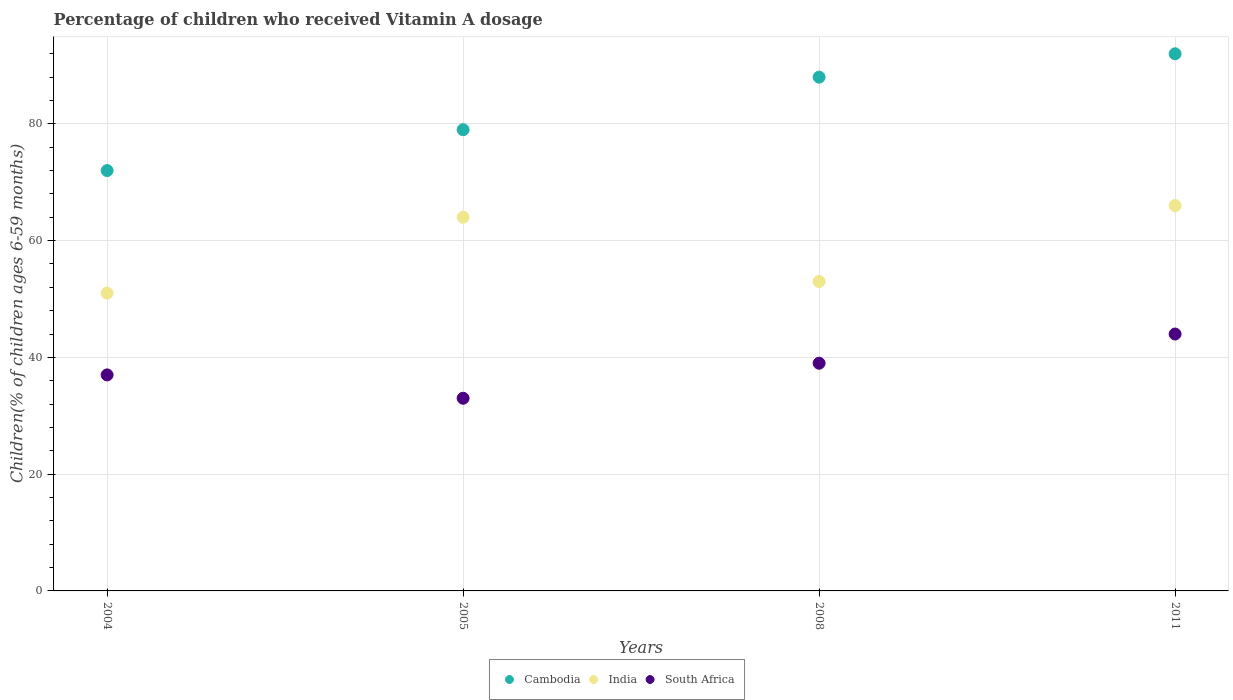Is the number of dotlines equal to the number of legend labels?
Offer a very short reply. Yes. Across all years, what is the maximum percentage of children who received Vitamin A dosage in India?
Your response must be concise. 66. In which year was the percentage of children who received Vitamin A dosage in India maximum?
Your answer should be compact. 2011. What is the total percentage of children who received Vitamin A dosage in India in the graph?
Provide a succinct answer. 234. What is the difference between the percentage of children who received Vitamin A dosage in Cambodia in 2004 and that in 2005?
Provide a short and direct response. -7. What is the difference between the percentage of children who received Vitamin A dosage in Cambodia in 2004 and the percentage of children who received Vitamin A dosage in India in 2008?
Offer a terse response. 19. What is the average percentage of children who received Vitamin A dosage in Cambodia per year?
Give a very brief answer. 82.75. In how many years, is the percentage of children who received Vitamin A dosage in Cambodia greater than 60 %?
Offer a terse response. 4. What is the ratio of the percentage of children who received Vitamin A dosage in India in 2008 to that in 2011?
Provide a succinct answer. 0.8. Is the percentage of children who received Vitamin A dosage in South Africa in 2005 less than that in 2008?
Provide a short and direct response. Yes. Is the difference between the percentage of children who received Vitamin A dosage in South Africa in 2008 and 2011 greater than the difference between the percentage of children who received Vitamin A dosage in India in 2008 and 2011?
Ensure brevity in your answer.  Yes. What is the difference between the highest and the second highest percentage of children who received Vitamin A dosage in India?
Keep it short and to the point. 2. What is the difference between the highest and the lowest percentage of children who received Vitamin A dosage in India?
Ensure brevity in your answer.  15. Is the sum of the percentage of children who received Vitamin A dosage in Cambodia in 2005 and 2011 greater than the maximum percentage of children who received Vitamin A dosage in India across all years?
Offer a very short reply. Yes. Is it the case that in every year, the sum of the percentage of children who received Vitamin A dosage in South Africa and percentage of children who received Vitamin A dosage in Cambodia  is greater than the percentage of children who received Vitamin A dosage in India?
Offer a very short reply. Yes. Does the percentage of children who received Vitamin A dosage in South Africa monotonically increase over the years?
Your answer should be very brief. No. How many years are there in the graph?
Give a very brief answer. 4. Does the graph contain any zero values?
Provide a short and direct response. No. How many legend labels are there?
Your answer should be compact. 3. How are the legend labels stacked?
Your answer should be compact. Horizontal. What is the title of the graph?
Ensure brevity in your answer.  Percentage of children who received Vitamin A dosage. What is the label or title of the Y-axis?
Offer a very short reply. Children(% of children ages 6-59 months). What is the Children(% of children ages 6-59 months) of Cambodia in 2005?
Keep it short and to the point. 79. What is the Children(% of children ages 6-59 months) in India in 2005?
Your response must be concise. 64. What is the Children(% of children ages 6-59 months) in South Africa in 2005?
Offer a very short reply. 33. What is the Children(% of children ages 6-59 months) of Cambodia in 2008?
Give a very brief answer. 88. What is the Children(% of children ages 6-59 months) in India in 2008?
Offer a very short reply. 53. What is the Children(% of children ages 6-59 months) of South Africa in 2008?
Make the answer very short. 39. What is the Children(% of children ages 6-59 months) in Cambodia in 2011?
Offer a very short reply. 92. What is the Children(% of children ages 6-59 months) of India in 2011?
Your answer should be compact. 66. Across all years, what is the maximum Children(% of children ages 6-59 months) in Cambodia?
Give a very brief answer. 92. Across all years, what is the minimum Children(% of children ages 6-59 months) in Cambodia?
Provide a succinct answer. 72. Across all years, what is the minimum Children(% of children ages 6-59 months) of South Africa?
Ensure brevity in your answer.  33. What is the total Children(% of children ages 6-59 months) of Cambodia in the graph?
Your answer should be very brief. 331. What is the total Children(% of children ages 6-59 months) in India in the graph?
Provide a succinct answer. 234. What is the total Children(% of children ages 6-59 months) in South Africa in the graph?
Give a very brief answer. 153. What is the difference between the Children(% of children ages 6-59 months) of Cambodia in 2004 and that in 2008?
Your answer should be very brief. -16. What is the difference between the Children(% of children ages 6-59 months) in Cambodia in 2005 and that in 2008?
Keep it short and to the point. -9. What is the difference between the Children(% of children ages 6-59 months) in South Africa in 2005 and that in 2008?
Give a very brief answer. -6. What is the difference between the Children(% of children ages 6-59 months) of Cambodia in 2005 and that in 2011?
Your answer should be compact. -13. What is the difference between the Children(% of children ages 6-59 months) of Cambodia in 2008 and that in 2011?
Offer a terse response. -4. What is the difference between the Children(% of children ages 6-59 months) of India in 2008 and that in 2011?
Offer a terse response. -13. What is the difference between the Children(% of children ages 6-59 months) in Cambodia in 2004 and the Children(% of children ages 6-59 months) in India in 2005?
Offer a terse response. 8. What is the difference between the Children(% of children ages 6-59 months) in Cambodia in 2004 and the Children(% of children ages 6-59 months) in India in 2011?
Make the answer very short. 6. What is the difference between the Children(% of children ages 6-59 months) in Cambodia in 2004 and the Children(% of children ages 6-59 months) in South Africa in 2011?
Your answer should be compact. 28. What is the difference between the Children(% of children ages 6-59 months) of India in 2004 and the Children(% of children ages 6-59 months) of South Africa in 2011?
Your answer should be compact. 7. What is the difference between the Children(% of children ages 6-59 months) in Cambodia in 2005 and the Children(% of children ages 6-59 months) in India in 2008?
Offer a very short reply. 26. What is the difference between the Children(% of children ages 6-59 months) of Cambodia in 2005 and the Children(% of children ages 6-59 months) of India in 2011?
Your response must be concise. 13. What is the difference between the Children(% of children ages 6-59 months) of India in 2005 and the Children(% of children ages 6-59 months) of South Africa in 2011?
Your response must be concise. 20. What is the difference between the Children(% of children ages 6-59 months) in Cambodia in 2008 and the Children(% of children ages 6-59 months) in South Africa in 2011?
Ensure brevity in your answer.  44. What is the difference between the Children(% of children ages 6-59 months) in India in 2008 and the Children(% of children ages 6-59 months) in South Africa in 2011?
Make the answer very short. 9. What is the average Children(% of children ages 6-59 months) in Cambodia per year?
Your answer should be very brief. 82.75. What is the average Children(% of children ages 6-59 months) of India per year?
Make the answer very short. 58.5. What is the average Children(% of children ages 6-59 months) in South Africa per year?
Keep it short and to the point. 38.25. In the year 2004, what is the difference between the Children(% of children ages 6-59 months) in India and Children(% of children ages 6-59 months) in South Africa?
Your answer should be compact. 14. In the year 2005, what is the difference between the Children(% of children ages 6-59 months) in India and Children(% of children ages 6-59 months) in South Africa?
Ensure brevity in your answer.  31. In the year 2008, what is the difference between the Children(% of children ages 6-59 months) in Cambodia and Children(% of children ages 6-59 months) in India?
Your answer should be very brief. 35. In the year 2008, what is the difference between the Children(% of children ages 6-59 months) in India and Children(% of children ages 6-59 months) in South Africa?
Give a very brief answer. 14. In the year 2011, what is the difference between the Children(% of children ages 6-59 months) of Cambodia and Children(% of children ages 6-59 months) of South Africa?
Provide a succinct answer. 48. What is the ratio of the Children(% of children ages 6-59 months) in Cambodia in 2004 to that in 2005?
Keep it short and to the point. 0.91. What is the ratio of the Children(% of children ages 6-59 months) of India in 2004 to that in 2005?
Your answer should be very brief. 0.8. What is the ratio of the Children(% of children ages 6-59 months) of South Africa in 2004 to that in 2005?
Offer a terse response. 1.12. What is the ratio of the Children(% of children ages 6-59 months) of Cambodia in 2004 to that in 2008?
Your answer should be compact. 0.82. What is the ratio of the Children(% of children ages 6-59 months) of India in 2004 to that in 2008?
Provide a short and direct response. 0.96. What is the ratio of the Children(% of children ages 6-59 months) of South Africa in 2004 to that in 2008?
Your answer should be very brief. 0.95. What is the ratio of the Children(% of children ages 6-59 months) in Cambodia in 2004 to that in 2011?
Offer a very short reply. 0.78. What is the ratio of the Children(% of children ages 6-59 months) in India in 2004 to that in 2011?
Your response must be concise. 0.77. What is the ratio of the Children(% of children ages 6-59 months) in South Africa in 2004 to that in 2011?
Your answer should be compact. 0.84. What is the ratio of the Children(% of children ages 6-59 months) in Cambodia in 2005 to that in 2008?
Make the answer very short. 0.9. What is the ratio of the Children(% of children ages 6-59 months) in India in 2005 to that in 2008?
Keep it short and to the point. 1.21. What is the ratio of the Children(% of children ages 6-59 months) in South Africa in 2005 to that in 2008?
Keep it short and to the point. 0.85. What is the ratio of the Children(% of children ages 6-59 months) of Cambodia in 2005 to that in 2011?
Your response must be concise. 0.86. What is the ratio of the Children(% of children ages 6-59 months) in India in 2005 to that in 2011?
Give a very brief answer. 0.97. What is the ratio of the Children(% of children ages 6-59 months) in South Africa in 2005 to that in 2011?
Provide a short and direct response. 0.75. What is the ratio of the Children(% of children ages 6-59 months) in Cambodia in 2008 to that in 2011?
Keep it short and to the point. 0.96. What is the ratio of the Children(% of children ages 6-59 months) in India in 2008 to that in 2011?
Offer a terse response. 0.8. What is the ratio of the Children(% of children ages 6-59 months) of South Africa in 2008 to that in 2011?
Your response must be concise. 0.89. What is the difference between the highest and the second highest Children(% of children ages 6-59 months) of Cambodia?
Keep it short and to the point. 4. What is the difference between the highest and the second highest Children(% of children ages 6-59 months) in South Africa?
Make the answer very short. 5. What is the difference between the highest and the lowest Children(% of children ages 6-59 months) in India?
Ensure brevity in your answer.  15. 